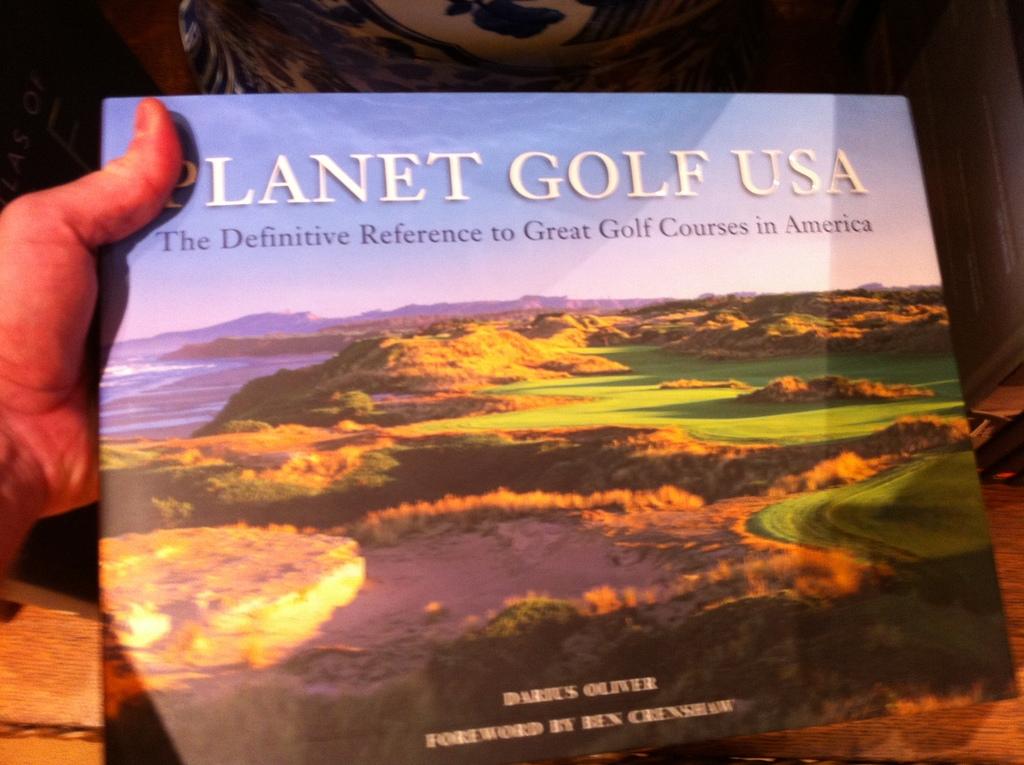What is the title of the book?
Provide a succinct answer. Planet golf usa. What is the subheading of the book?
Offer a terse response. The definitive reference to great golf courses in america. 